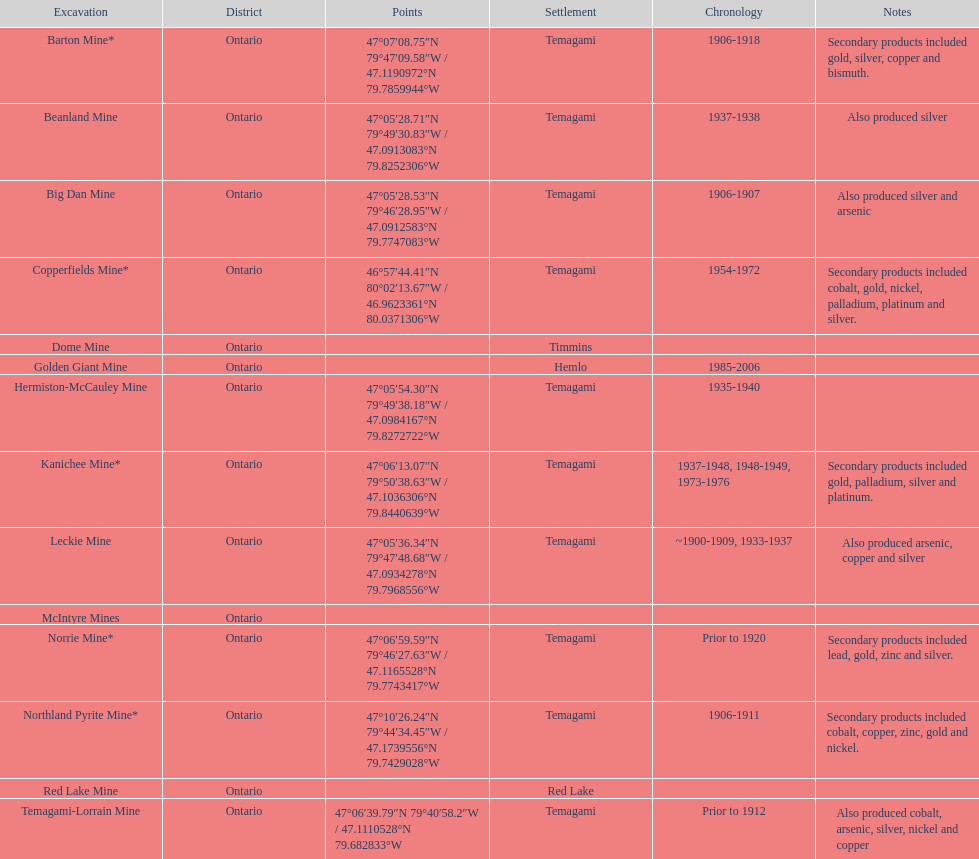How many times is temagami listedon the list? 10. 